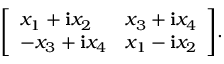Convert formula to latex. <formula><loc_0><loc_0><loc_500><loc_500>{ \left [ \begin{array} { l l } { x _ { 1 } + i x _ { 2 } } & { x _ { 3 } + i x _ { 4 } } \\ { - x _ { 3 } + i x _ { 4 } } & { x _ { 1 } - i x _ { 2 } } \end{array} \right ] } . \,</formula> 